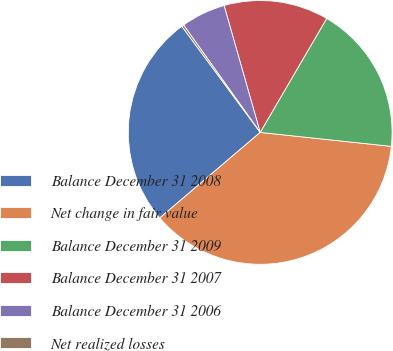Convert chart. <chart><loc_0><loc_0><loc_500><loc_500><pie_chart><fcel>Balance December 31 2008<fcel>Net change in fair value<fcel>Balance December 31 2009<fcel>Balance December 31 2007<fcel>Balance December 31 2006<fcel>Net realized losses<nl><fcel>26.11%<fcel>37.08%<fcel>18.28%<fcel>12.82%<fcel>5.45%<fcel>0.26%<nl></chart> 